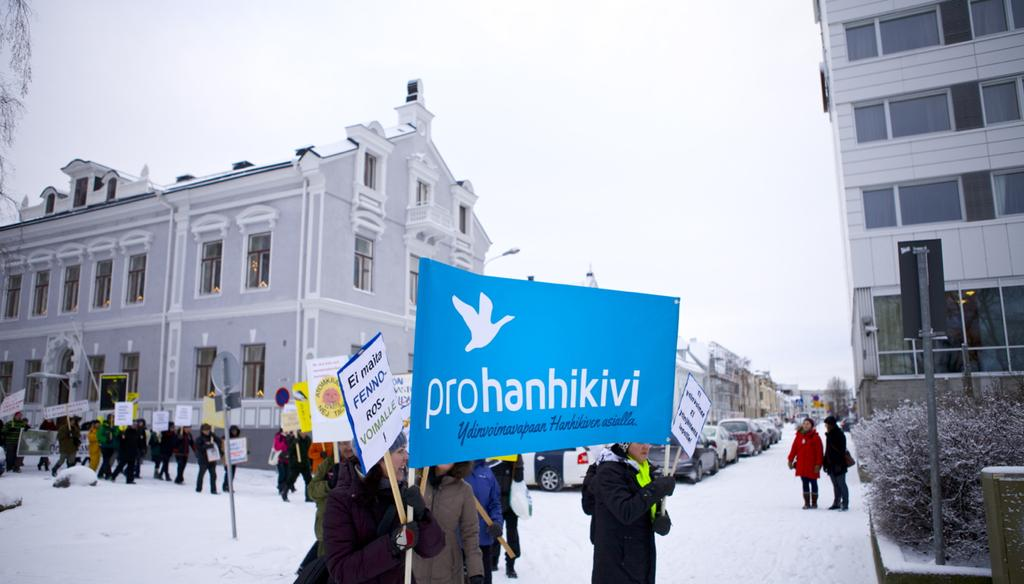<image>
Describe the image concisely. A group of demonstrators gather on a snowy street, some holding a pro hanhikivi sign. 